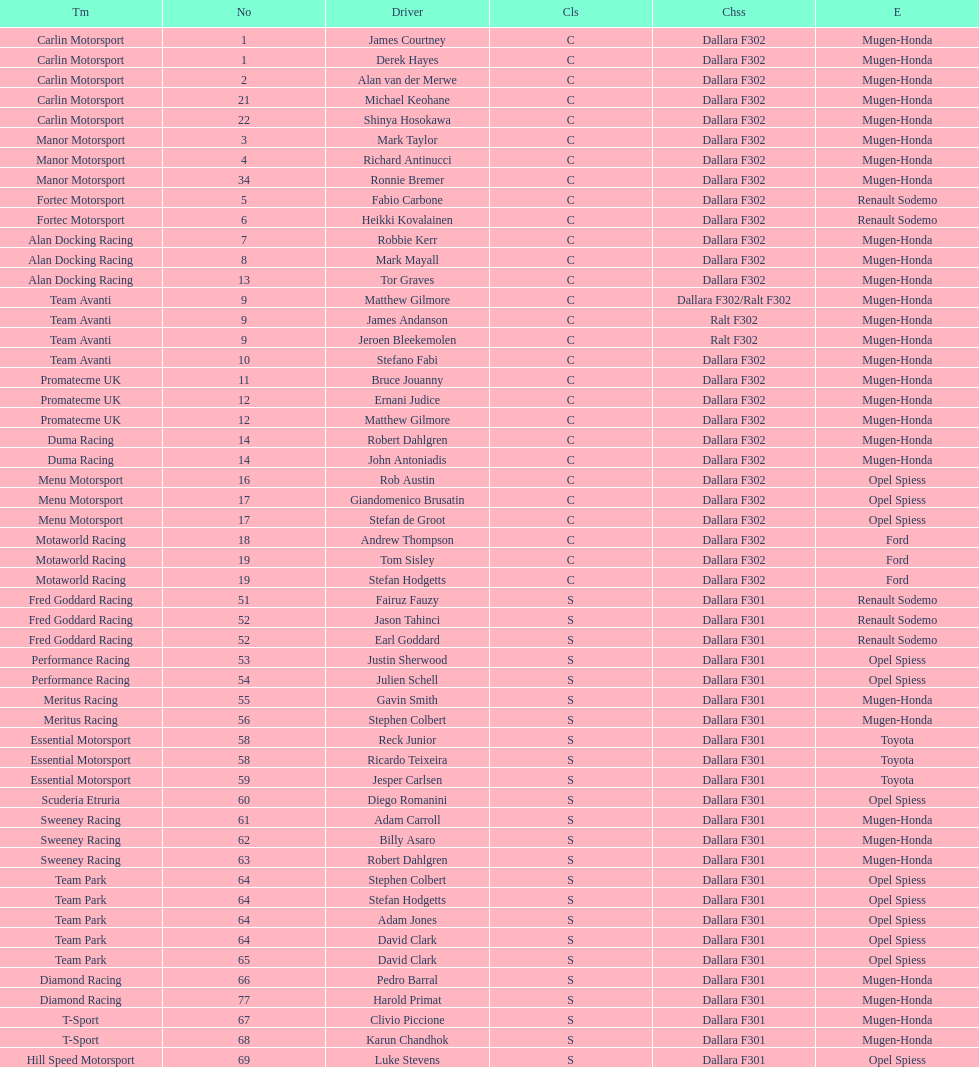The two drivers on t-sport are clivio piccione and what other driver? Karun Chandhok. 